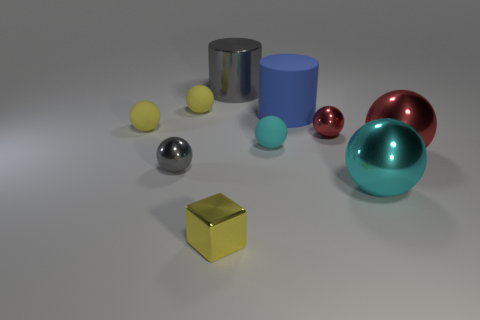Is the number of tiny metal things that are behind the tiny cyan sphere greater than the number of red objects behind the large matte cylinder? Upon careful observation of the image, it appears that there are equal numbers of tiny metal things behind the cyan sphere and red objects behind the large matte cylinder. The complexity of determining the exact nature of objects based on their appearance and their position in relation to one another in the image can sometimes be subjective. However, to the best of my discernment, each group consists of a single item, leading to a balanced count rather than one exceeding the other. 